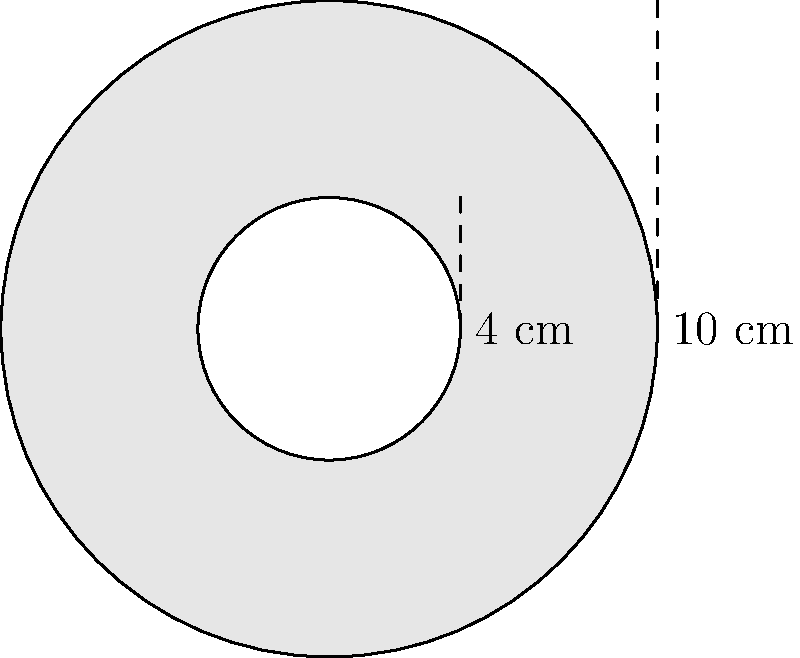As part of your latest film project, you need to create a set piece shaped like a film reel. The outer diameter of the reel is 10 cm, and the inner diameter (where the film is fed through) is 4 cm. Calculate the area of the film reel-shaped set piece in square centimeters. To find the area of the film reel-shaped set piece, we need to:

1. Calculate the area of the larger circle (outer diameter)
2. Calculate the area of the smaller circle (inner diameter)
3. Subtract the area of the smaller circle from the larger circle

Step 1: Area of the larger circle
- Radius = Diameter ÷ 2 = 10 cm ÷ 2 = 5 cm
- Area = $\pi r^2$ = $\pi (5 \text{ cm})^2$ = $25\pi \text{ cm}^2$

Step 2: Area of the smaller circle
- Radius = Diameter ÷ 2 = 4 cm ÷ 2 = 2 cm
- Area = $\pi r^2$ = $\pi (2 \text{ cm})^2$ = $4\pi \text{ cm}^2$

Step 3: Subtract the smaller area from the larger area
Film reel area = Larger circle area - Smaller circle area
$= 25\pi \text{ cm}^2 - 4\pi \text{ cm}^2$
$= 21\pi \text{ cm}^2$

Therefore, the area of the film reel-shaped set piece is $21\pi \text{ cm}^2$ or approximately 65.97 cm².
Answer: $21\pi \text{ cm}^2$ or 65.97 cm² 